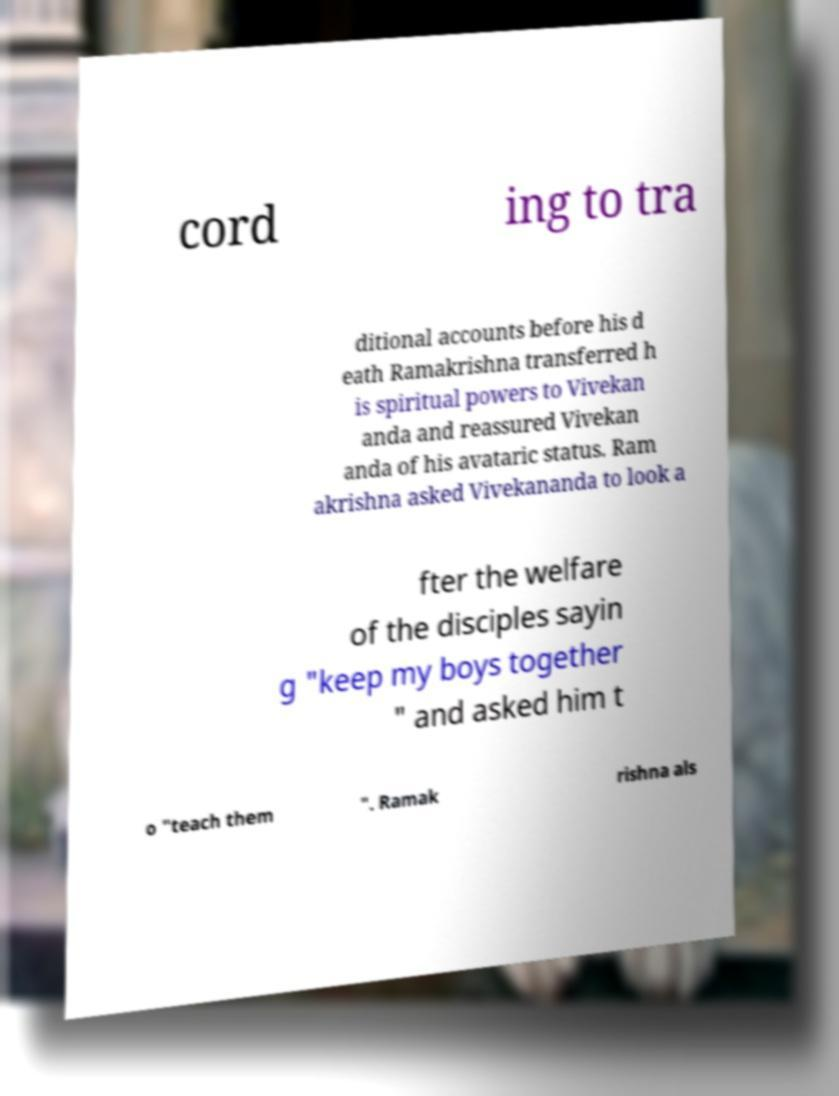There's text embedded in this image that I need extracted. Can you transcribe it verbatim? cord ing to tra ditional accounts before his d eath Ramakrishna transferred h is spiritual powers to Vivekan anda and reassured Vivekan anda of his avataric status. Ram akrishna asked Vivekananda to look a fter the welfare of the disciples sayin g "keep my boys together " and asked him t o "teach them ". Ramak rishna als 